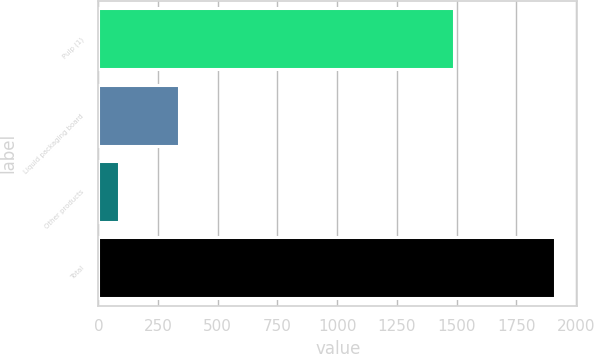Convert chart. <chart><loc_0><loc_0><loc_500><loc_500><bar_chart><fcel>Pulp (1)<fcel>Liquid packaging board<fcel>Other products<fcel>Total<nl><fcel>1489<fcel>337<fcel>85<fcel>1911<nl></chart> 